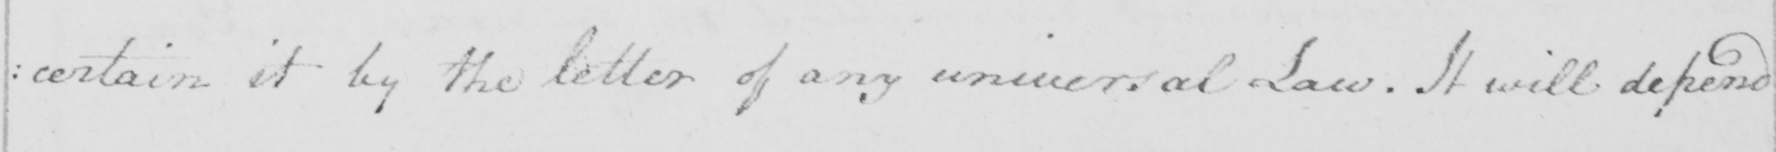Please transcribe the handwritten text in this image. : certain it by the letter of any universal Law . It will depend 